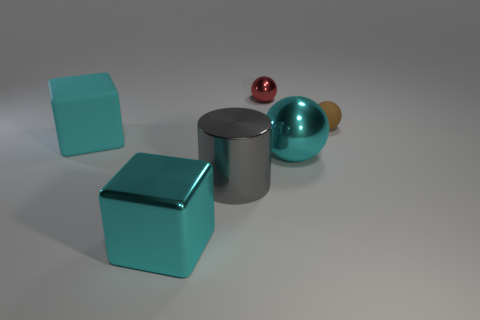Subtract all big cyan shiny spheres. How many spheres are left? 2 Add 3 brown rubber blocks. How many objects exist? 9 Subtract all red balls. How many balls are left? 2 Subtract all blocks. How many objects are left? 4 Add 3 tiny brown matte things. How many tiny brown matte things exist? 4 Subtract 0 brown cubes. How many objects are left? 6 Subtract all yellow blocks. Subtract all green cylinders. How many blocks are left? 2 Subtract all small blue metallic spheres. Subtract all small brown objects. How many objects are left? 5 Add 3 matte cubes. How many matte cubes are left? 4 